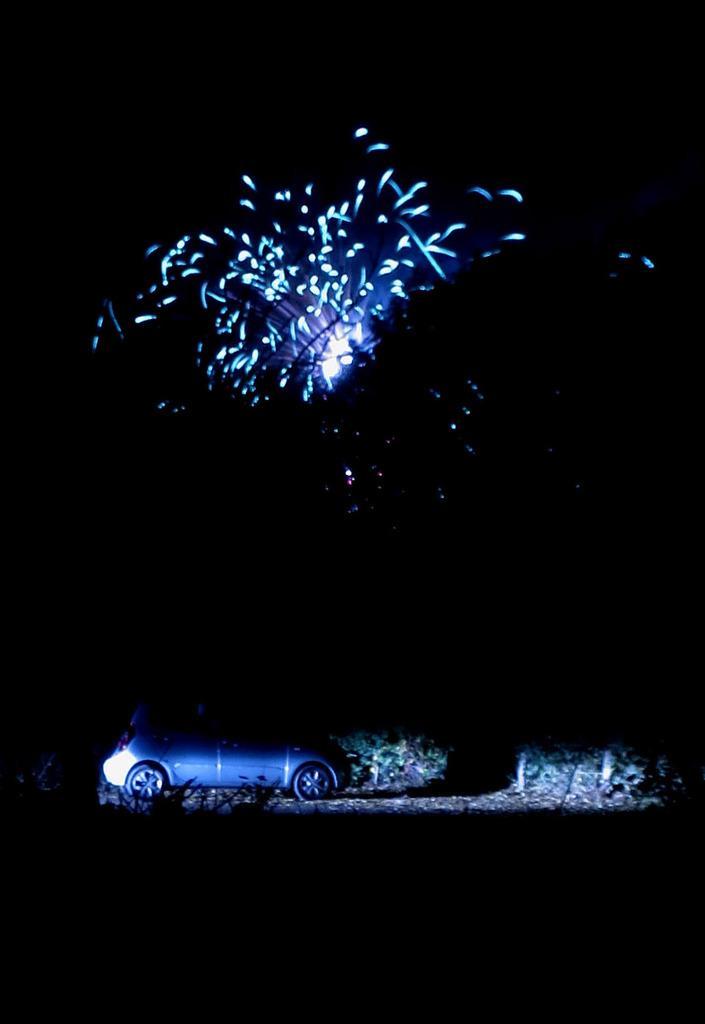Can you describe this image briefly? In this image in the center there is one car, and in the background there are some trees and some lights. 